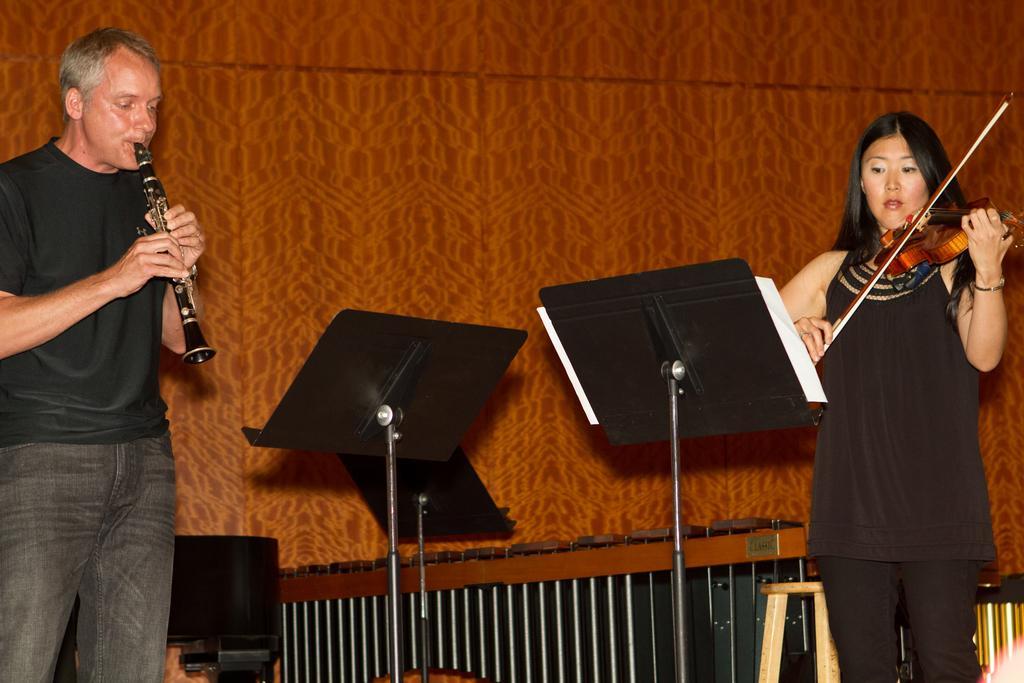Can you describe this image briefly? In the image we can see there are two people who are standing. A woman is holding a violin in her hand and the man is holding a musical instrument. 